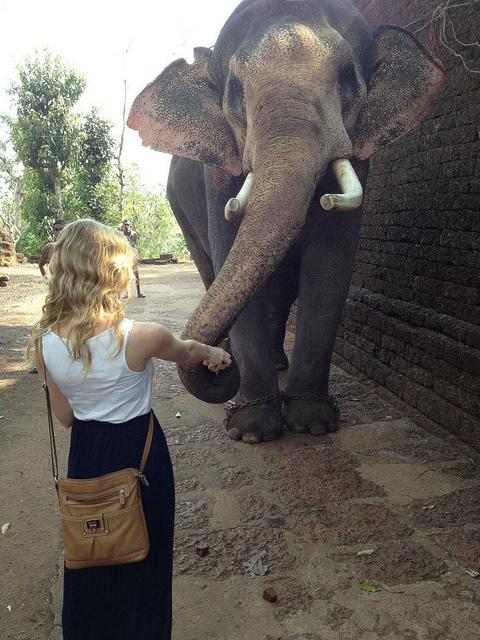What are the white things sticking out below the animal's nose?
Write a very short answer. Tusks. Where is the woman?
Quick response, please. Zoo. Is this a toy elephant?
Be succinct. No. Is the woman in danger?
Be succinct. No. What color hair does the woman have?
Write a very short answer. Blonde. Is there a person in the picture?
Concise answer only. Yes. How many tusk are visible?
Short answer required. 2. 